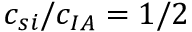Convert formula to latex. <formula><loc_0><loc_0><loc_500><loc_500>c _ { s i } / c _ { I A } = 1 / 2</formula> 